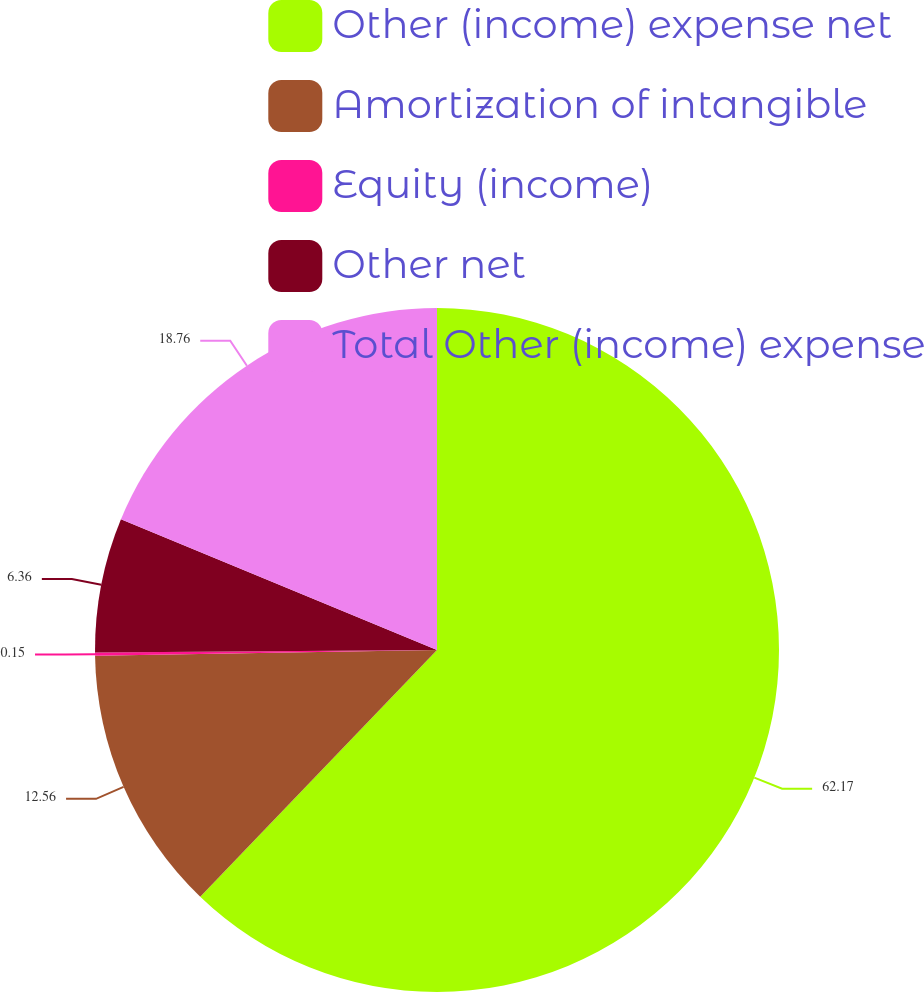<chart> <loc_0><loc_0><loc_500><loc_500><pie_chart><fcel>Other (income) expense net<fcel>Amortization of intangible<fcel>Equity (income)<fcel>Other net<fcel>Total Other (income) expense<nl><fcel>62.17%<fcel>12.56%<fcel>0.15%<fcel>6.36%<fcel>18.76%<nl></chart> 